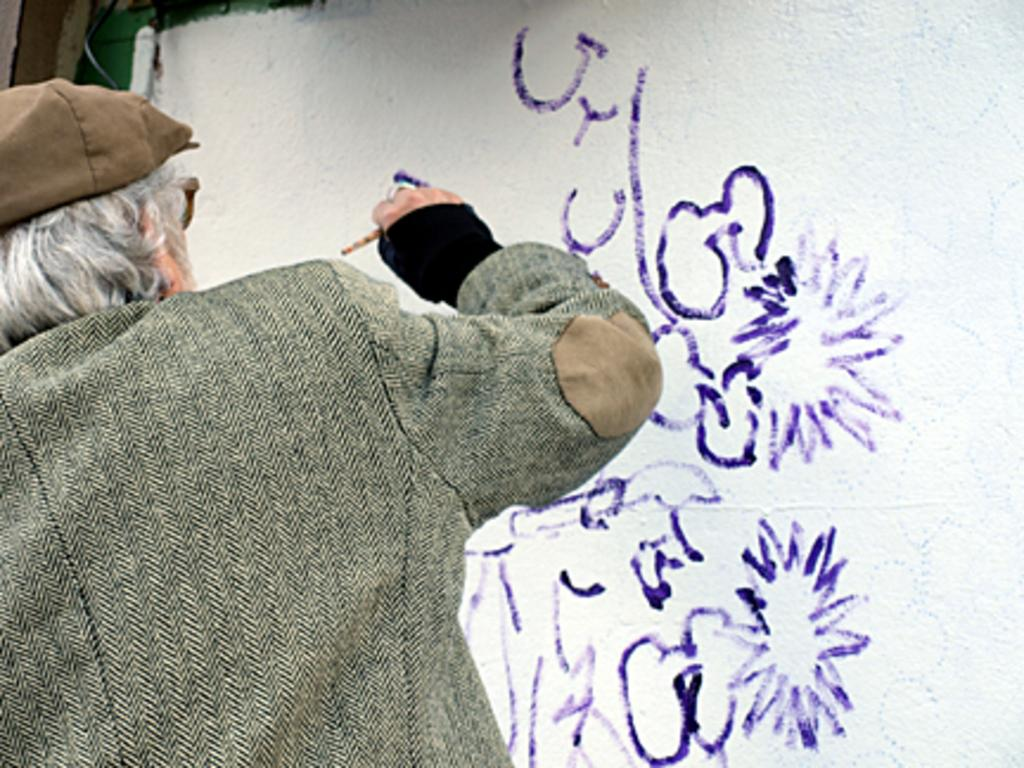Who is the main subject in the image? There is a man in the image. What is the man holding in the image? The man is holding a brush. What is the man doing with the brush? The man is painting on a cloth. What type of punishment is the man receiving in the image? There is no indication in the image that the man is receiving any punishment; he is simply painting on a cloth. 